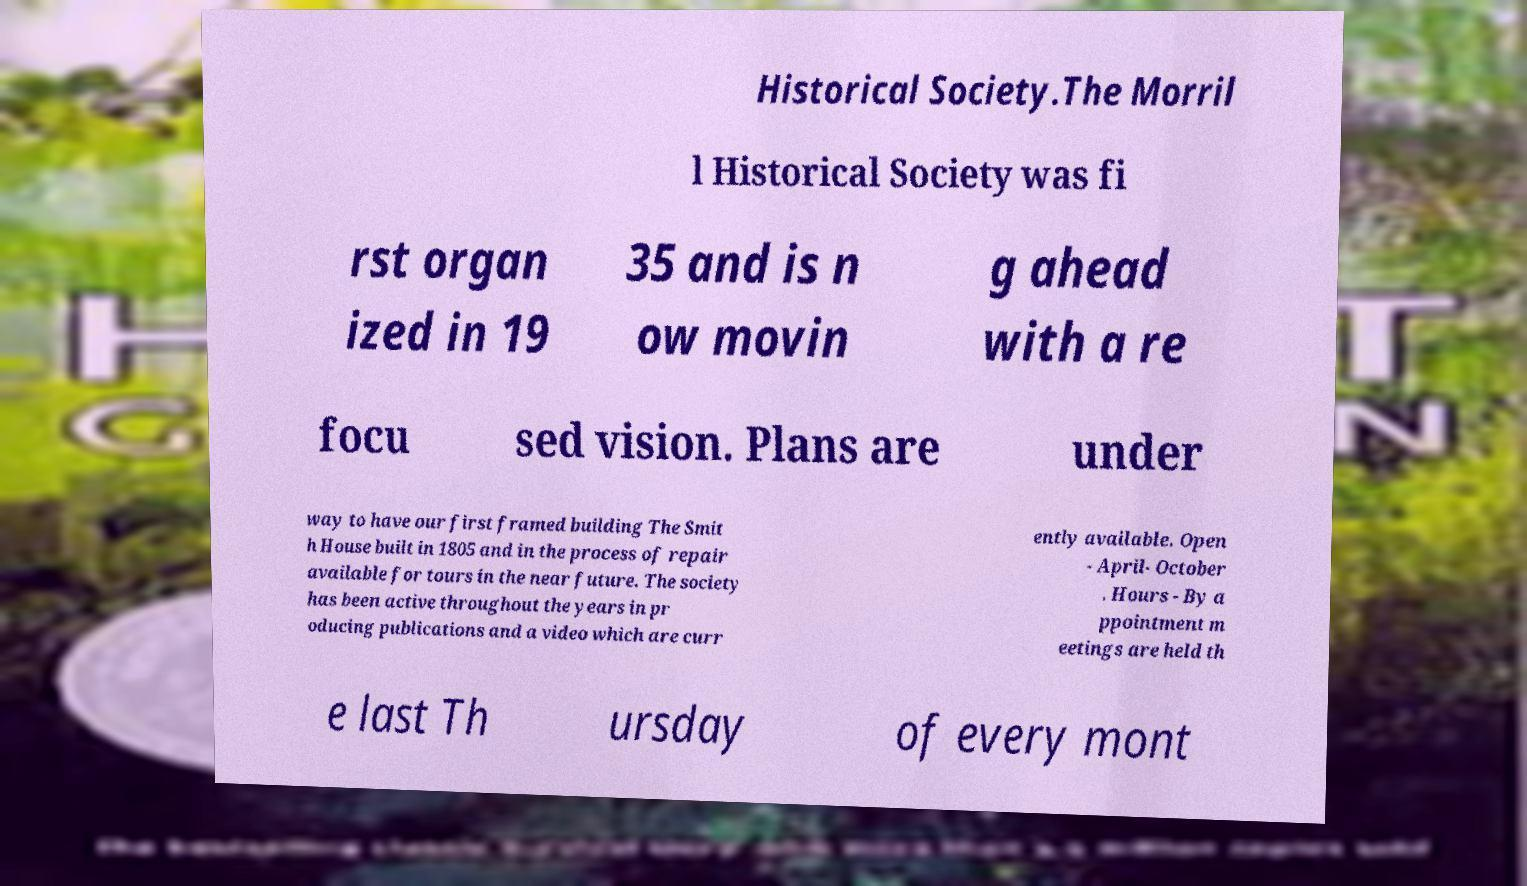For documentation purposes, I need the text within this image transcribed. Could you provide that? Historical Society.The Morril l Historical Society was fi rst organ ized in 19 35 and is n ow movin g ahead with a re focu sed vision. Plans are under way to have our first framed building The Smit h House built in 1805 and in the process of repair available for tours in the near future. The society has been active throughout the years in pr oducing publications and a video which are curr ently available. Open - April- October . Hours - By a ppointment m eetings are held th e last Th ursday of every mont 